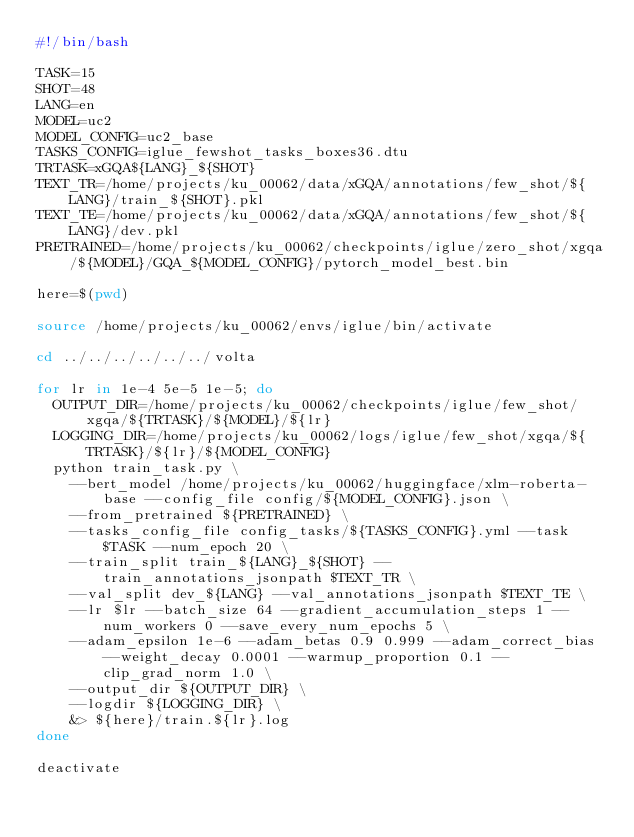Convert code to text. <code><loc_0><loc_0><loc_500><loc_500><_Bash_>#!/bin/bash

TASK=15
SHOT=48
LANG=en
MODEL=uc2
MODEL_CONFIG=uc2_base
TASKS_CONFIG=iglue_fewshot_tasks_boxes36.dtu
TRTASK=xGQA${LANG}_${SHOT}
TEXT_TR=/home/projects/ku_00062/data/xGQA/annotations/few_shot/${LANG}/train_${SHOT}.pkl
TEXT_TE=/home/projects/ku_00062/data/xGQA/annotations/few_shot/${LANG}/dev.pkl
PRETRAINED=/home/projects/ku_00062/checkpoints/iglue/zero_shot/xgqa/${MODEL}/GQA_${MODEL_CONFIG}/pytorch_model_best.bin

here=$(pwd)

source /home/projects/ku_00062/envs/iglue/bin/activate

cd ../../../../../../volta

for lr in 1e-4 5e-5 1e-5; do
  OUTPUT_DIR=/home/projects/ku_00062/checkpoints/iglue/few_shot/xgqa/${TRTASK}/${MODEL}/${lr}
  LOGGING_DIR=/home/projects/ku_00062/logs/iglue/few_shot/xgqa/${TRTASK}/${lr}/${MODEL_CONFIG}
  python train_task.py \
    --bert_model /home/projects/ku_00062/huggingface/xlm-roberta-base --config_file config/${MODEL_CONFIG}.json \
    --from_pretrained ${PRETRAINED} \
    --tasks_config_file config_tasks/${TASKS_CONFIG}.yml --task $TASK --num_epoch 20 \
    --train_split train_${LANG}_${SHOT} --train_annotations_jsonpath $TEXT_TR \
    --val_split dev_${LANG} --val_annotations_jsonpath $TEXT_TE \
    --lr $lr --batch_size 64 --gradient_accumulation_steps 1 --num_workers 0 --save_every_num_epochs 5 \
    --adam_epsilon 1e-6 --adam_betas 0.9 0.999 --adam_correct_bias --weight_decay 0.0001 --warmup_proportion 0.1 --clip_grad_norm 1.0 \
    --output_dir ${OUTPUT_DIR} \
    --logdir ${LOGGING_DIR} \
    &> ${here}/train.${lr}.log
done

deactivate
</code> 